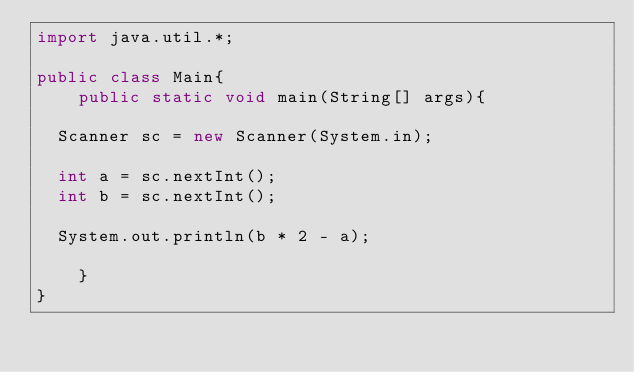Convert code to text. <code><loc_0><loc_0><loc_500><loc_500><_Java_>import java.util.*;

public class Main{
    public static void main(String[] args){

	Scanner sc = new Scanner(System.in);

	int a = sc.nextInt();
	int b = sc.nextInt();

	System.out.println(b * 2 - a);

    }
}
</code> 